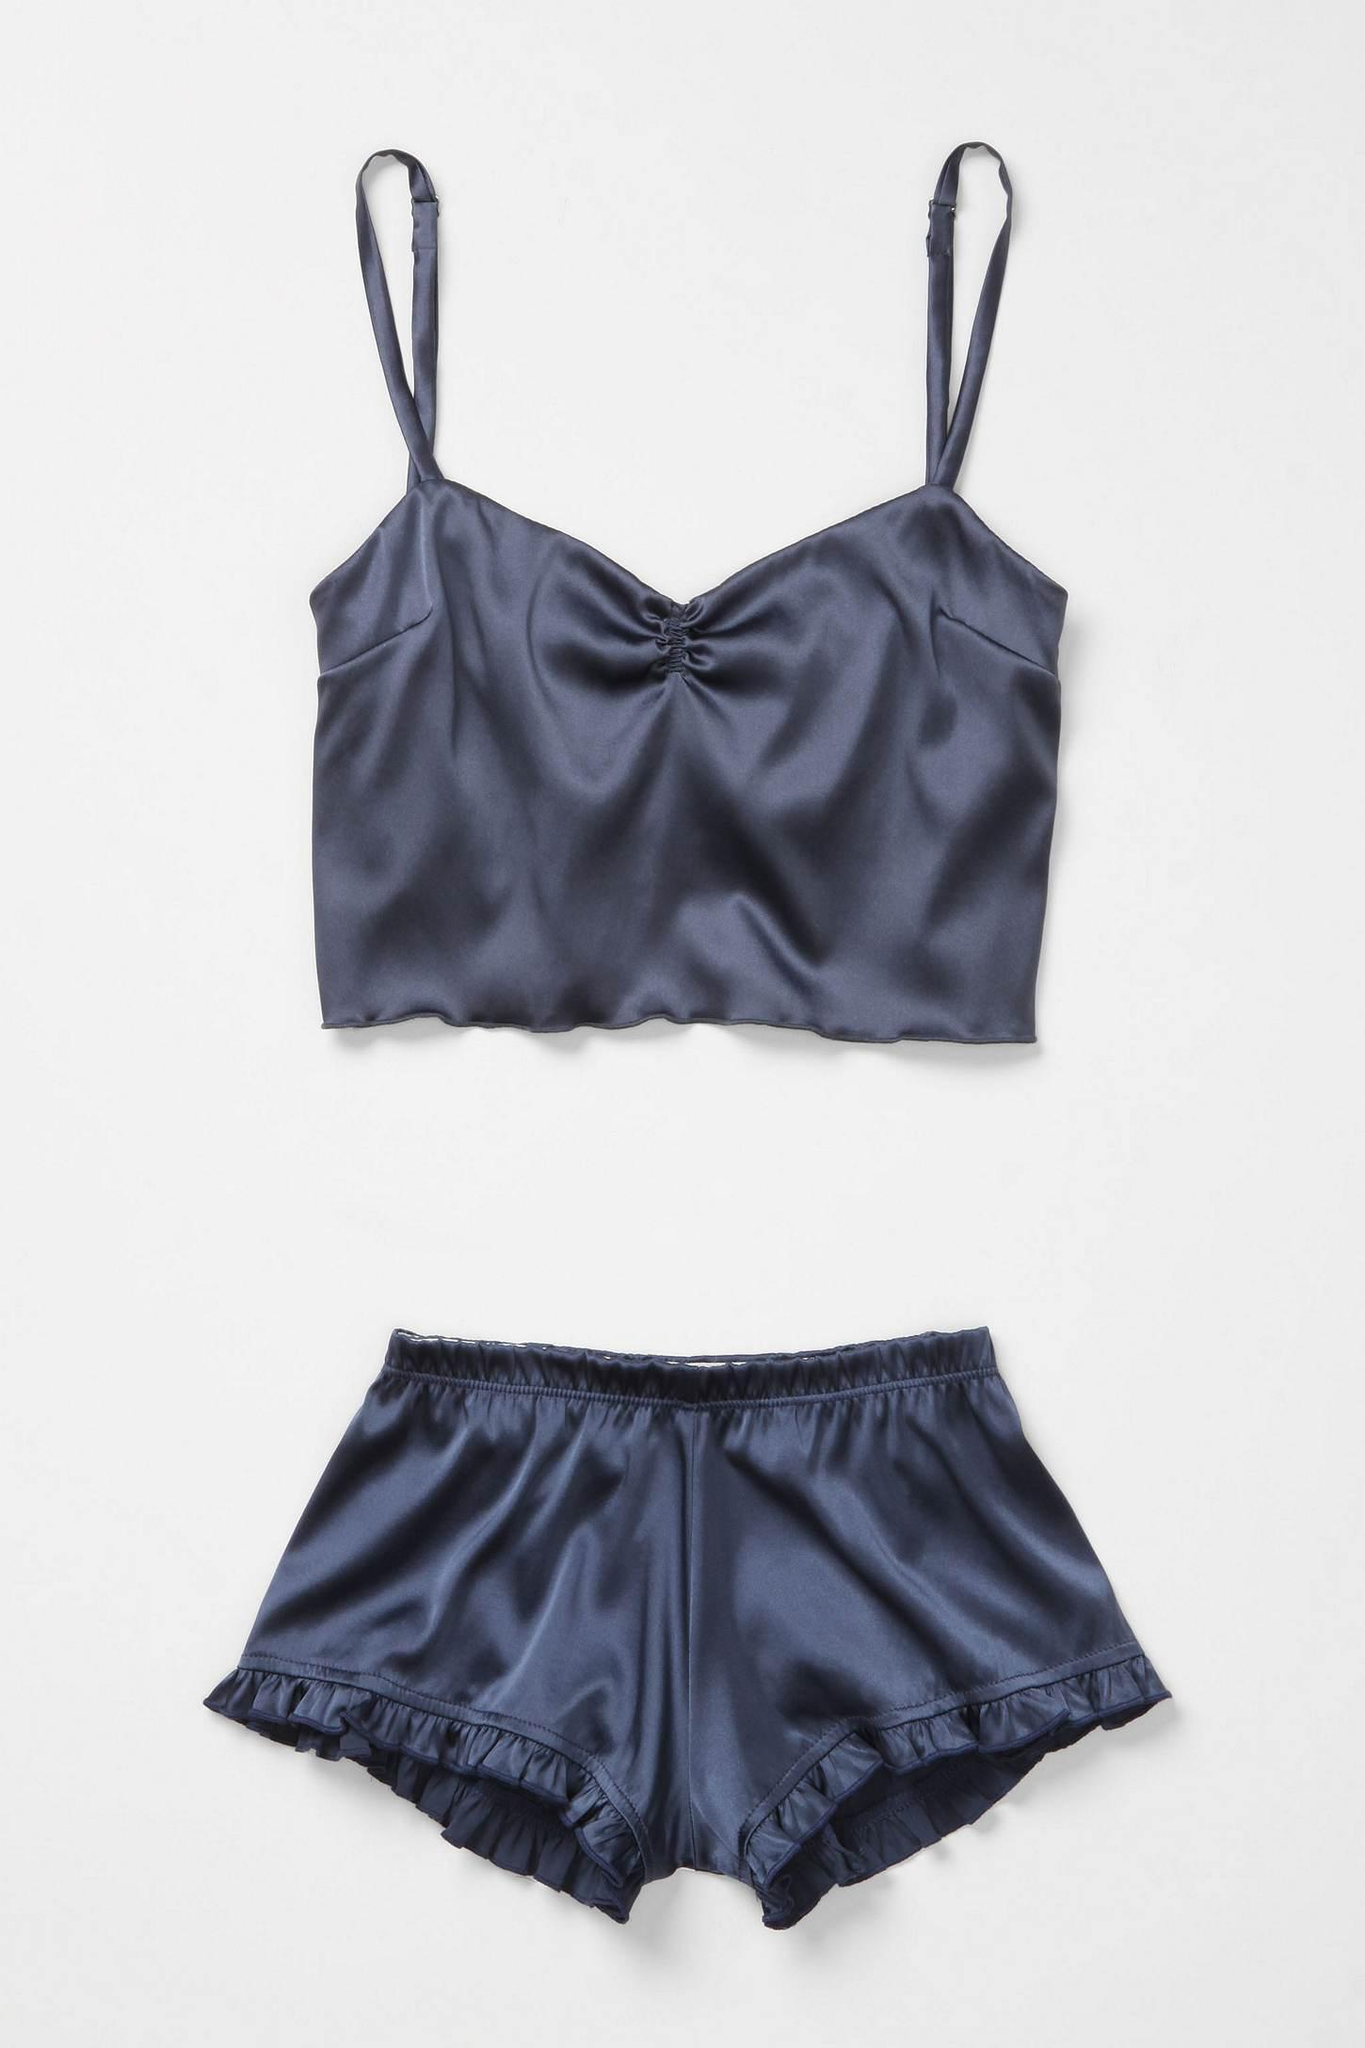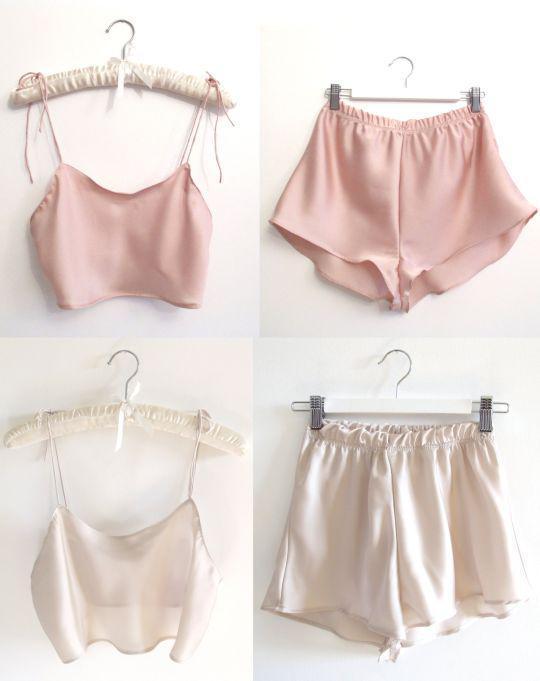The first image is the image on the left, the second image is the image on the right. Considering the images on both sides, is "Images feature matching dark lingerie sets and peachy colored sets, but none are worn by human models." valid? Answer yes or no. Yes. The first image is the image on the left, the second image is the image on the right. Considering the images on both sides, is "There is one set of lingerie in the image on the left." valid? Answer yes or no. Yes. 